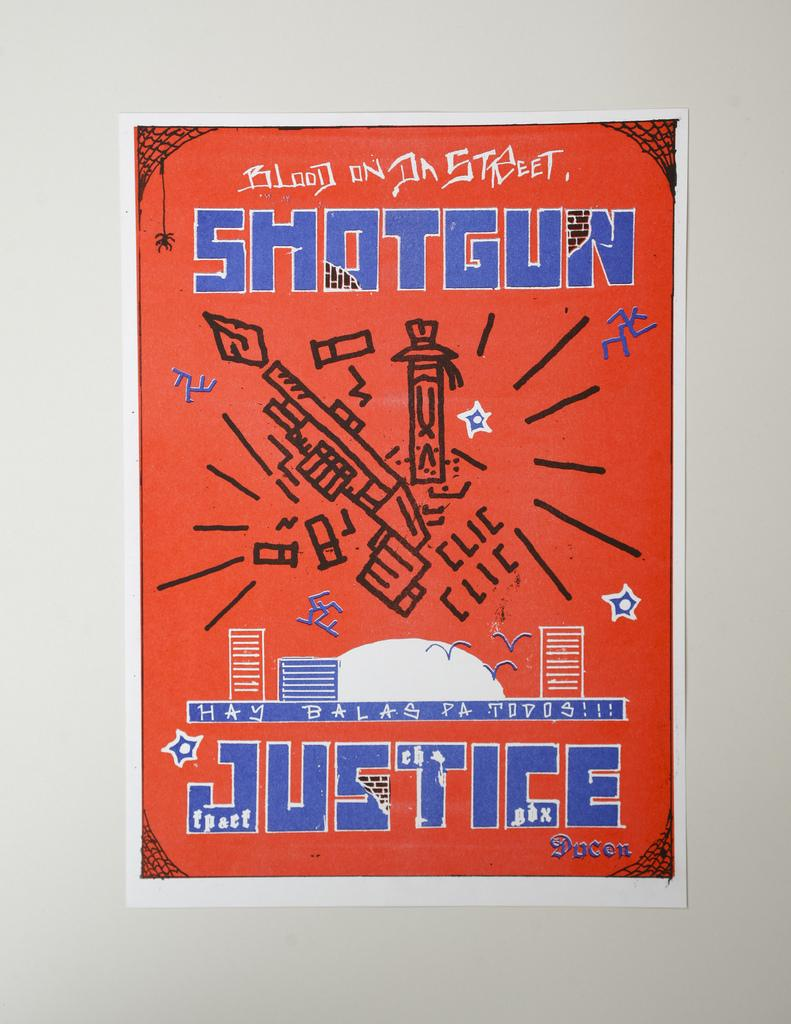Provide a one-sentence caption for the provided image. Poster that says the word Justice on the bottom. 